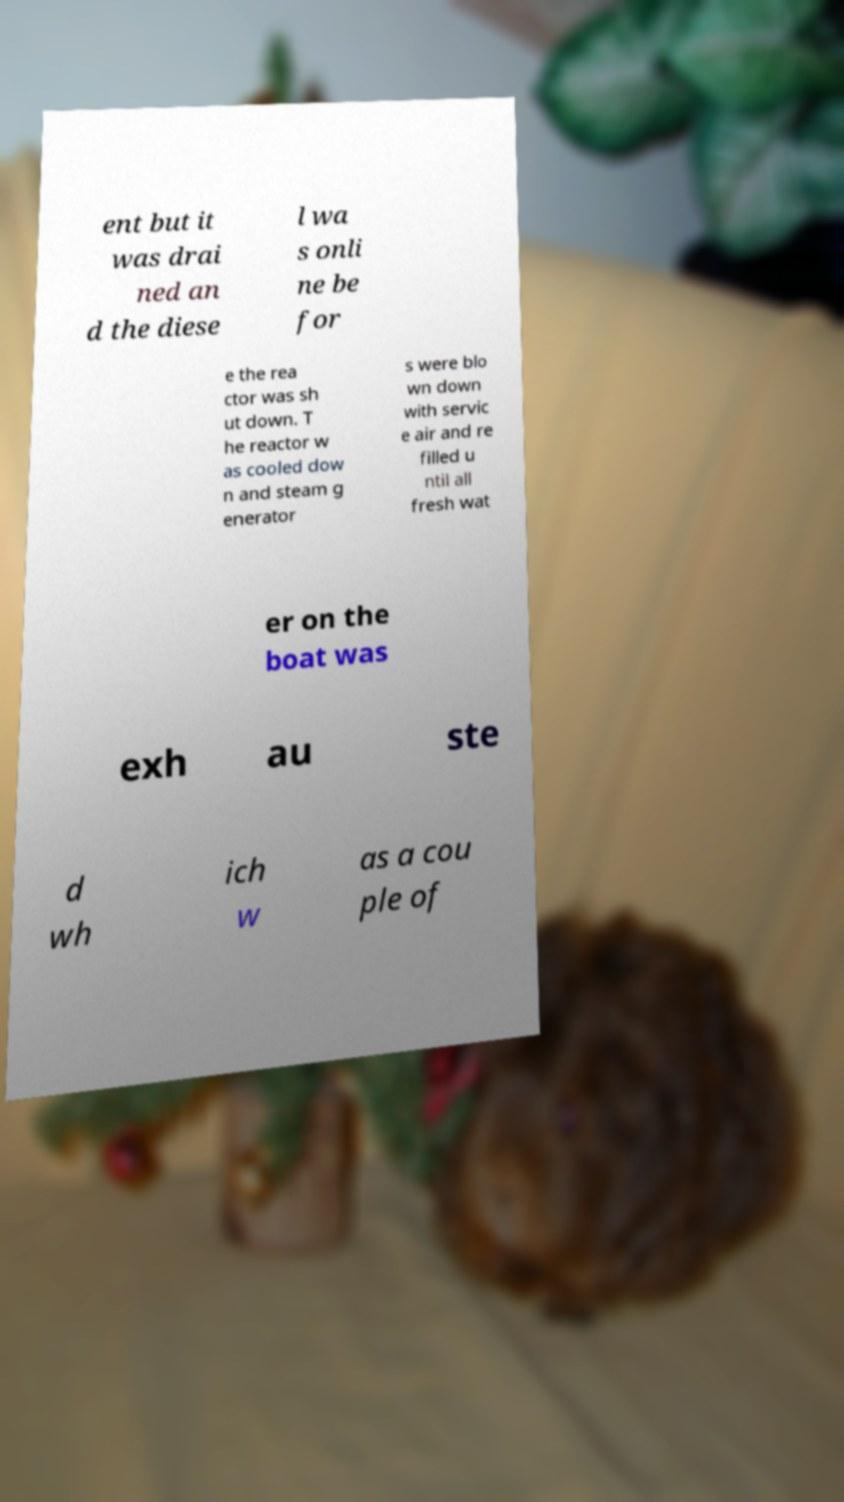Could you extract and type out the text from this image? ent but it was drai ned an d the diese l wa s onli ne be for e the rea ctor was sh ut down. T he reactor w as cooled dow n and steam g enerator s were blo wn down with servic e air and re filled u ntil all fresh wat er on the boat was exh au ste d wh ich w as a cou ple of 